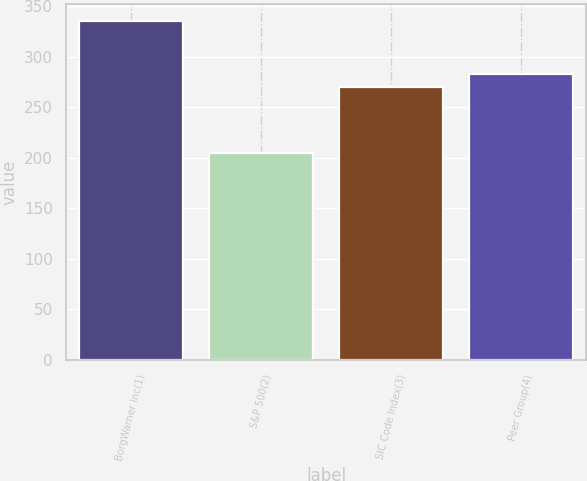Convert chart. <chart><loc_0><loc_0><loc_500><loc_500><bar_chart><fcel>BorgWarner Inc(1)<fcel>S&P 500(2)<fcel>SIC Code Index(3)<fcel>Peer Group(4)<nl><fcel>335.39<fcel>205.14<fcel>270.25<fcel>283.27<nl></chart> 